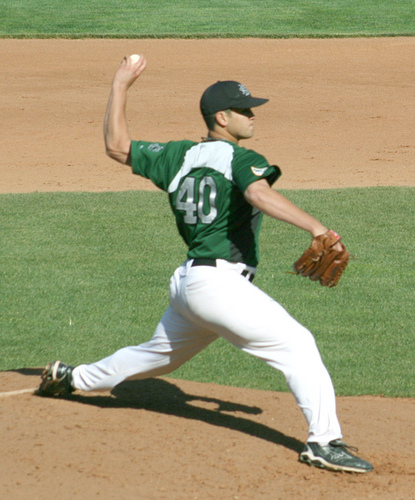Read all the text in this image. 40 